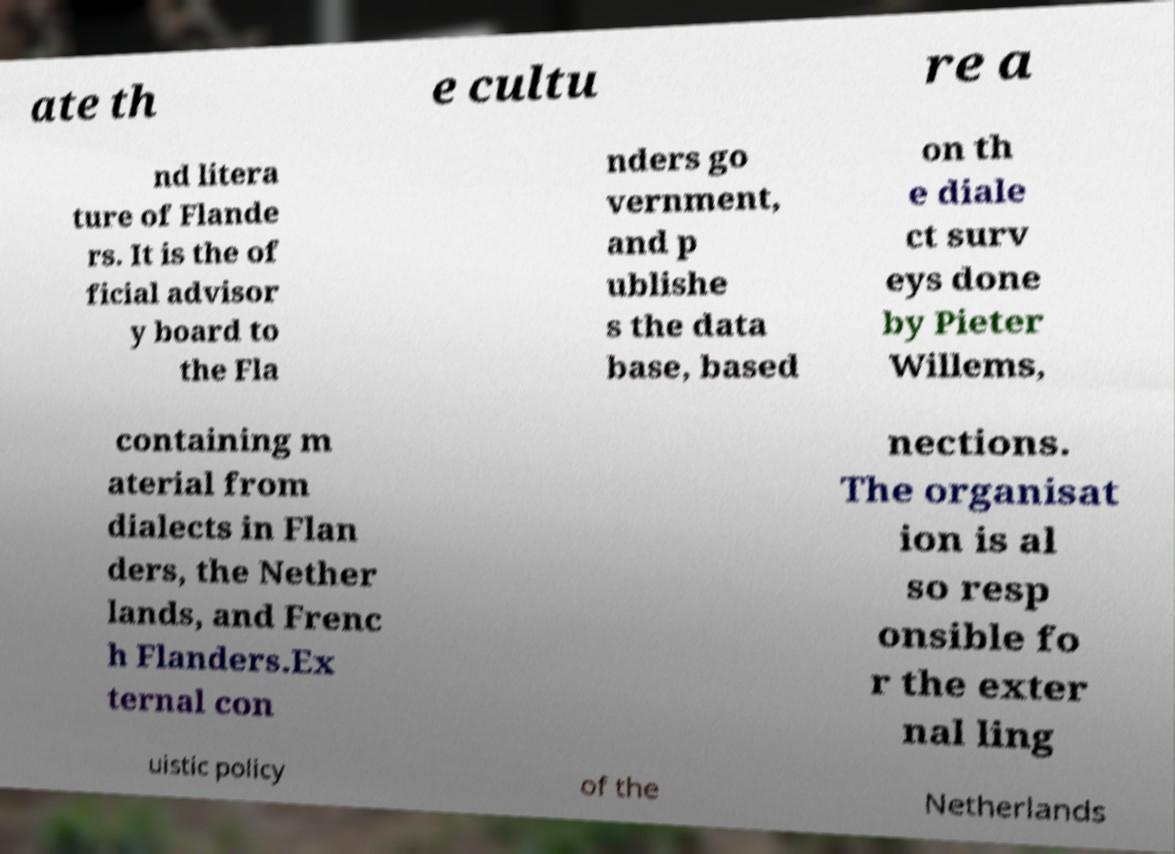Please identify and transcribe the text found in this image. ate th e cultu re a nd litera ture of Flande rs. It is the of ficial advisor y board to the Fla nders go vernment, and p ublishe s the data base, based on th e diale ct surv eys done by Pieter Willems, containing m aterial from dialects in Flan ders, the Nether lands, and Frenc h Flanders.Ex ternal con nections. The organisat ion is al so resp onsible fo r the exter nal ling uistic policy of the Netherlands 